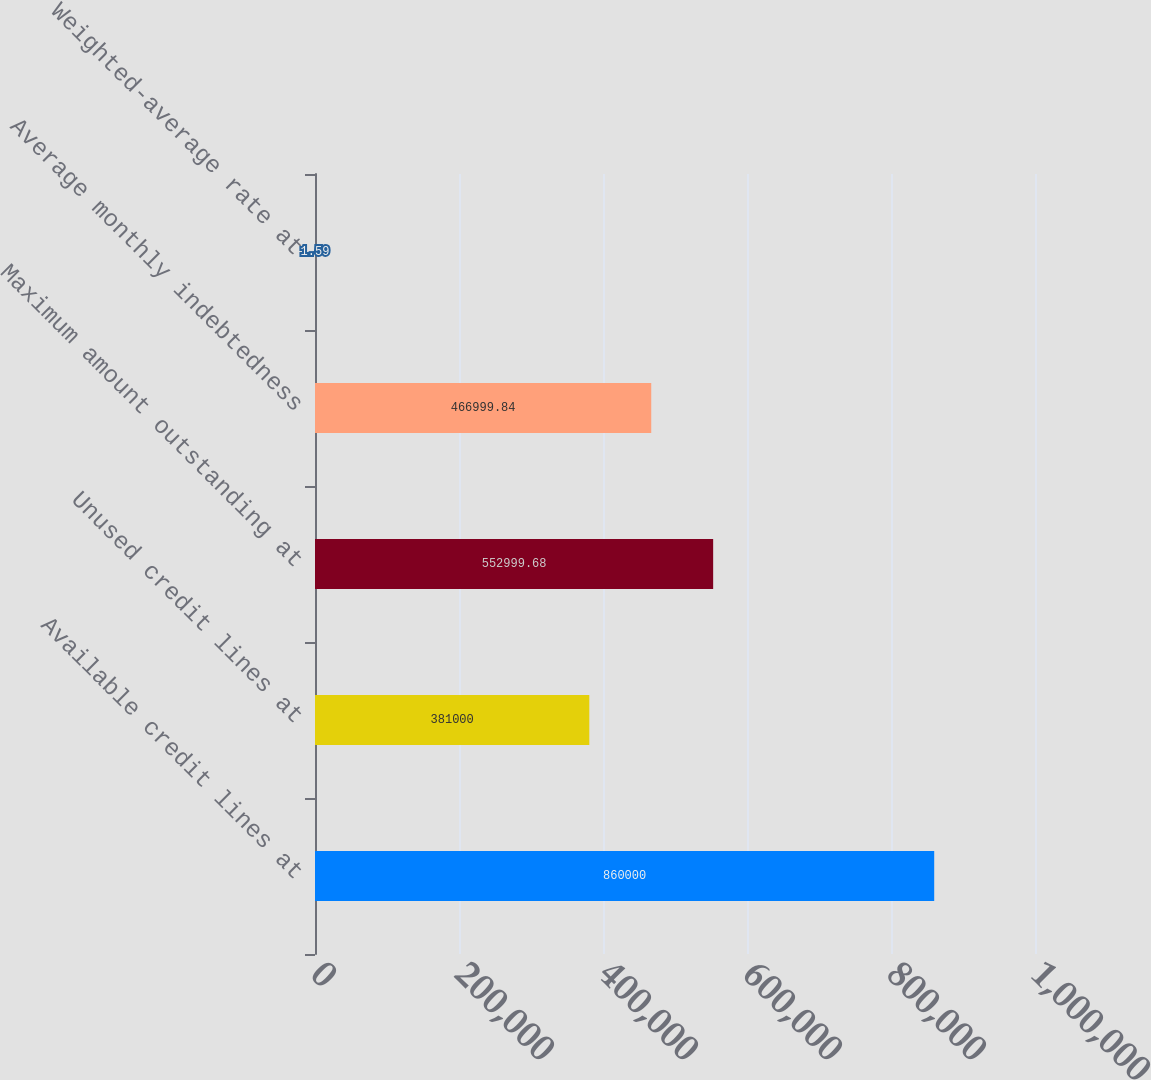<chart> <loc_0><loc_0><loc_500><loc_500><bar_chart><fcel>Available credit lines at<fcel>Unused credit lines at<fcel>Maximum amount outstanding at<fcel>Average monthly indebtedness<fcel>Weighted-average rate at<nl><fcel>860000<fcel>381000<fcel>553000<fcel>467000<fcel>1.59<nl></chart> 